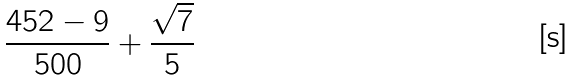<formula> <loc_0><loc_0><loc_500><loc_500>\frac { 4 5 2 - 9 } { 5 0 0 } + \frac { \sqrt { 7 } } { 5 }</formula> 